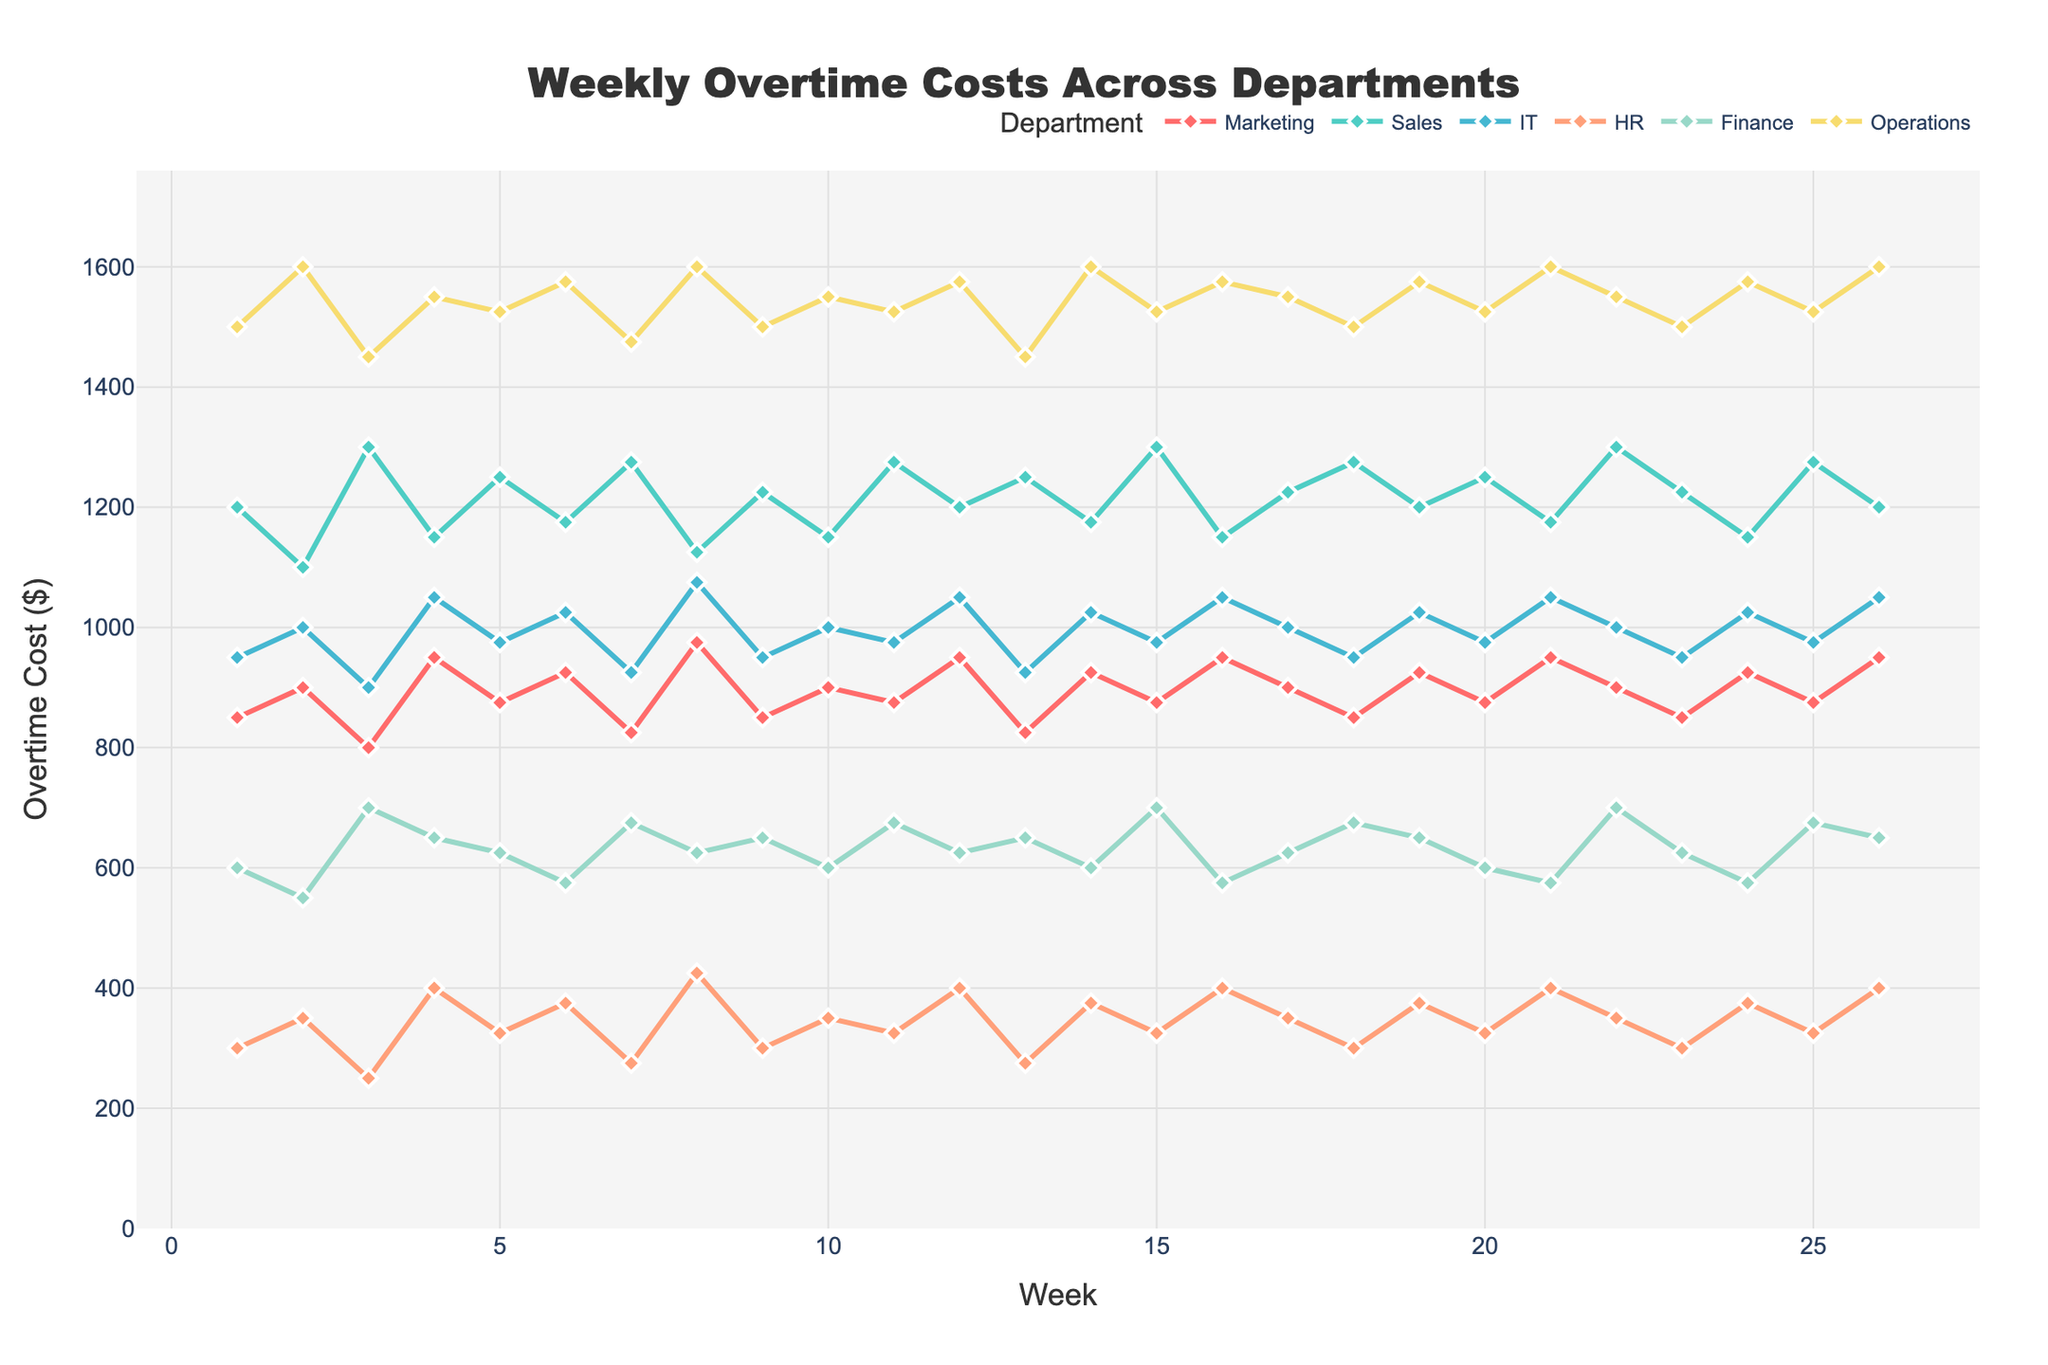What is the trend of overtime costs in the Operations department over the first 6 weeks? In the first 6 weeks, the overtime costs for the Operations department are as follows: Week 1 (1500), Week 2 (1600), Week 3 (1450), Week 4 (1550), Week 5 (1525), and Week 6 (1575). The trend shows an initial increase, a drop in Week 3, followed by a general upward movement.
Answer: Upward Which department had the highest overtime cost in Week 15? In Week 15, the overtime costs were: Marketing (875), Sales (1300), IT (975), HR (325), Finance (700), and Operations (1525). Among these, the Operations department had the highest overtime cost.
Answer: Operations What is the average overtime cost for the HR department across all weeks? Summing the overtime costs for HR across all weeks: (300 + 350 + 250 + 400 + 325 + 375 + 275 + 425 + 300 + 350 + 325 + 400 + 275 + 375 + 325 + 400 + 350 + 300 + 375 + 325 + 400 + 350 + 300 + 375 + 325 + 400) yields 8600. Dividing this by 26 gives an average overtime cost of 8600/26 ≈ 330.77.
Answer: 330.77 During which week did the Marketing department report its highest overtime cost? From the dataset, Marketing's highest overtime cost was 975, which occurred in Week 8 and Week 16.
Answer: Week 8 and Week 16 How do the overtime costs for IT and Finance compare in Week 10? In Week 10, the overtime cost for IT is 1000 and for Finance it is 600. The overtime cost for IT is higher than that for Finance.
Answer: IT > Finance Which department had the most variation in overtime costs over the 26 weeks? To determine the department with the most variation, we analyze the range (difference between maximum and minimum values) for each department: Marketing (150), Sales (200), IT (150), HR (175), Finance (125), Operations (150). Sales had the most variation.
Answer: Sales What is the median overtime cost for the Sales department? Sorting the Sales overtime costs (1100, 1150, 1150, 1150, 1175, 1175, 1200, 1200, 1225, 1225, 1250, 1250, 1250, 1275, 1275, 1300, 1300, 1300) and then taking the average of the 13th and 14th values (1275 and 1225) yields a median of 1250.
Answer: 1250 In which week did the Finance department incur the lowest overtime cost, and what was the amount? The lowest overtime cost for Finance was observed in Week 2 and Week 10, both with an amount of 550.
Answer: Week 2 and Week 10, 550 Compare the average overtime costs for Marketing and HR. Which has the higher average? Summing the overtime costs for Marketing: (850 + 900 + 800 + 950 + 875 + 925 + 825 + 975 + 850 + 900 + 875 + 950 + 825 + 925 + 875 + 950 + 900 + 850 + 925 + 875 + 950 + 900 + 850 + 925 + 875 + 950) yields 23025. Dividing by 26 gives an average of 885.58. For HR, the sum is 8600, and the average is 330.77. Marketing has the higher average.
Answer: Marketing What week had the highest combined overtime cost for IT and HR? Adding IT and HR costs for each week, Week 8 stands out with IT (1075) + HR (425), giving a combined total of 1500.
Answer: Week 8 